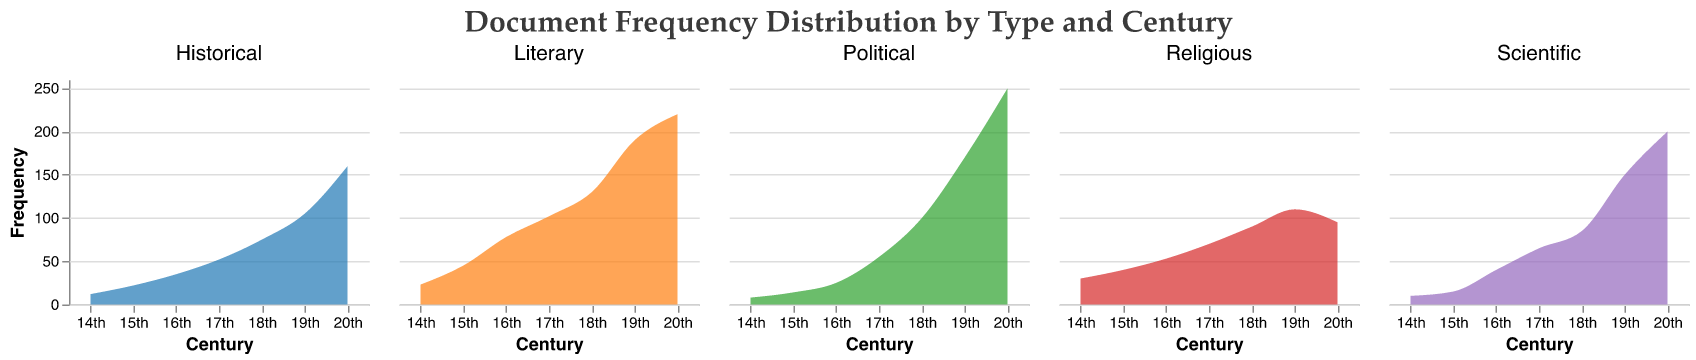What is the title of the figure? The title of the figure is located at the top and typically describes the content of the plot. In this case, it is "Document Frequency Distribution by Type and Century".
Answer: Document Frequency Distribution by Type and Century Which century has the highest frequency of Political documents? To determine the century with the highest frequency of Political documents, look for the peak value in the Political subplot. The 20th century shows the highest frequency.
Answer: 20th How does the frequency of Literary documents change from the 14th to the 20th century? Observing the trend line in the Literary subplot from the 14th to the 20th century, you can see a steady increase in frequency with some acceleration in the later centuries.
Answer: Increases Compare the frequency of Scientific documents in the 18th and 20th centuries. In the Scientific subplot, the frequency in the 18th century is 85 and increases to 200 in the 20th century.
Answer: The 20th century has a higher frequency Which document type has the least fluctuation in frequency across centuries? By comparing the variation in the frequency lines of all document types, one can observe that the Religious documents show the least fluctuation, remaining relatively stable.
Answer: Religious What are the approximate frequencies of Historical documents in the 15th and 19th centuries? Looking at the Historical subplot, the frequency in the 15th century is about 22, and in the 19th century, it is about 105.
Answer: 22 (15th century), 105 (19th century) What is the overall trend in the frequency of documents over the centuries? By looking at all subplots, it is apparent that the frequencies generally increase over time, especially accelerating in the 19th and 20th centuries.
Answer: Increasing trend Which document type experiences the largest increase in frequency from the 14th to the 20th century? Comparing the start and end points in each subplot, Political documents see the largest increase, from 8 in the 14th century to 250 in the 20th century.
Answer: Political How does the frequency of Religious documents in the 20th century compare to that in the 19th century? In the subplot for Religious documents, the frequency in the 20th century is 95, which is a slight decrease from the 110 in the 19th century.
Answer: Decreases What is the frequency of Scientific documents in the 14th century? The frequency of Scientific documents in the 14th century is explicitly shown in the plot.
Answer: 10 